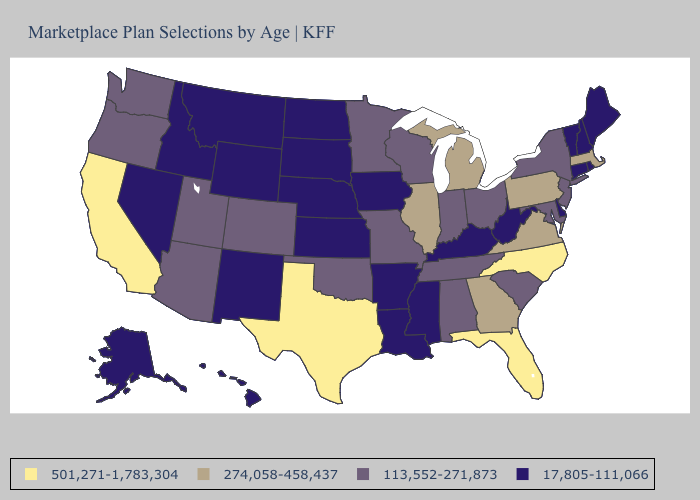What is the highest value in the MidWest ?
Write a very short answer. 274,058-458,437. Among the states that border Kentucky , does Indiana have the highest value?
Quick response, please. No. Name the states that have a value in the range 17,805-111,066?
Write a very short answer. Alaska, Arkansas, Connecticut, Delaware, Hawaii, Idaho, Iowa, Kansas, Kentucky, Louisiana, Maine, Mississippi, Montana, Nebraska, Nevada, New Hampshire, New Mexico, North Dakota, Rhode Island, South Dakota, Vermont, West Virginia, Wyoming. Name the states that have a value in the range 274,058-458,437?
Give a very brief answer. Georgia, Illinois, Massachusetts, Michigan, Pennsylvania, Virginia. Does Pennsylvania have the same value as Indiana?
Give a very brief answer. No. Is the legend a continuous bar?
Concise answer only. No. Which states hav the highest value in the West?
Write a very short answer. California. What is the highest value in states that border Arizona?
Be succinct. 501,271-1,783,304. Name the states that have a value in the range 113,552-271,873?
Keep it brief. Alabama, Arizona, Colorado, Indiana, Maryland, Minnesota, Missouri, New Jersey, New York, Ohio, Oklahoma, Oregon, South Carolina, Tennessee, Utah, Washington, Wisconsin. Name the states that have a value in the range 17,805-111,066?
Give a very brief answer. Alaska, Arkansas, Connecticut, Delaware, Hawaii, Idaho, Iowa, Kansas, Kentucky, Louisiana, Maine, Mississippi, Montana, Nebraska, Nevada, New Hampshire, New Mexico, North Dakota, Rhode Island, South Dakota, Vermont, West Virginia, Wyoming. Name the states that have a value in the range 17,805-111,066?
Keep it brief. Alaska, Arkansas, Connecticut, Delaware, Hawaii, Idaho, Iowa, Kansas, Kentucky, Louisiana, Maine, Mississippi, Montana, Nebraska, Nevada, New Hampshire, New Mexico, North Dakota, Rhode Island, South Dakota, Vermont, West Virginia, Wyoming. What is the value of Arizona?
Write a very short answer. 113,552-271,873. Which states have the lowest value in the MidWest?
Concise answer only. Iowa, Kansas, Nebraska, North Dakota, South Dakota. Name the states that have a value in the range 17,805-111,066?
Write a very short answer. Alaska, Arkansas, Connecticut, Delaware, Hawaii, Idaho, Iowa, Kansas, Kentucky, Louisiana, Maine, Mississippi, Montana, Nebraska, Nevada, New Hampshire, New Mexico, North Dakota, Rhode Island, South Dakota, Vermont, West Virginia, Wyoming. Which states have the highest value in the USA?
Concise answer only. California, Florida, North Carolina, Texas. 